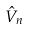Convert formula to latex. <formula><loc_0><loc_0><loc_500><loc_500>\hat { V } _ { n }</formula> 